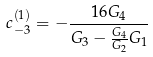<formula> <loc_0><loc_0><loc_500><loc_500>c _ { - 3 } ^ { ( 1 ) } = - \frac { 1 6 G _ { 4 } } { G _ { 3 } - \frac { G _ { 4 } } { G _ { 2 } } G _ { 1 } }</formula> 